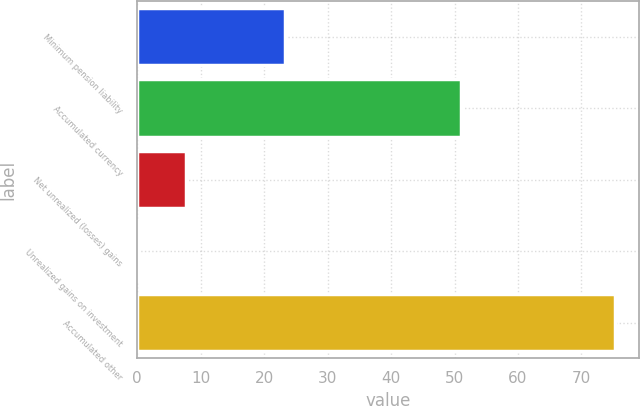<chart> <loc_0><loc_0><loc_500><loc_500><bar_chart><fcel>Minimum pension liability<fcel>Accumulated currency<fcel>Net unrealized (losses) gains<fcel>Unrealized gains on investment<fcel>Accumulated other<nl><fcel>23.3<fcel>51<fcel>7.62<fcel>0.1<fcel>75.3<nl></chart> 